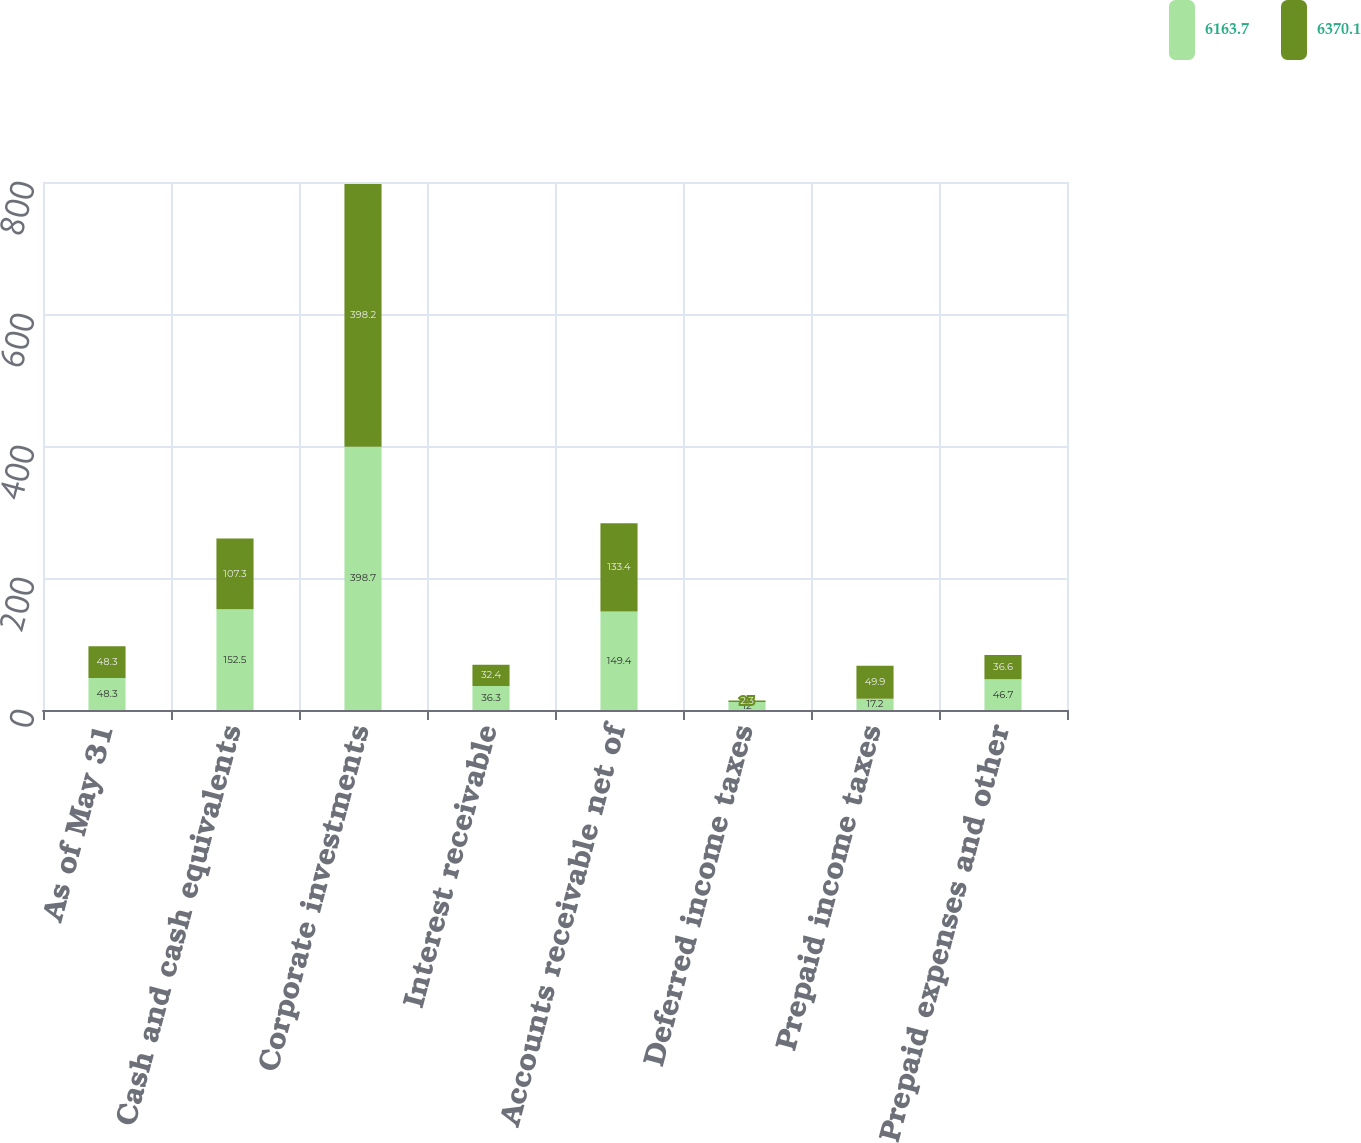<chart> <loc_0><loc_0><loc_500><loc_500><stacked_bar_chart><ecel><fcel>As of May 31<fcel>Cash and cash equivalents<fcel>Corporate investments<fcel>Interest receivable<fcel>Accounts receivable net of<fcel>Deferred income taxes<fcel>Prepaid income taxes<fcel>Prepaid expenses and other<nl><fcel>6163.7<fcel>48.3<fcel>152.5<fcel>398.7<fcel>36.3<fcel>149.4<fcel>12<fcel>17.2<fcel>46.7<nl><fcel>6370.1<fcel>48.3<fcel>107.3<fcel>398.2<fcel>32.4<fcel>133.4<fcel>2.3<fcel>49.9<fcel>36.6<nl></chart> 